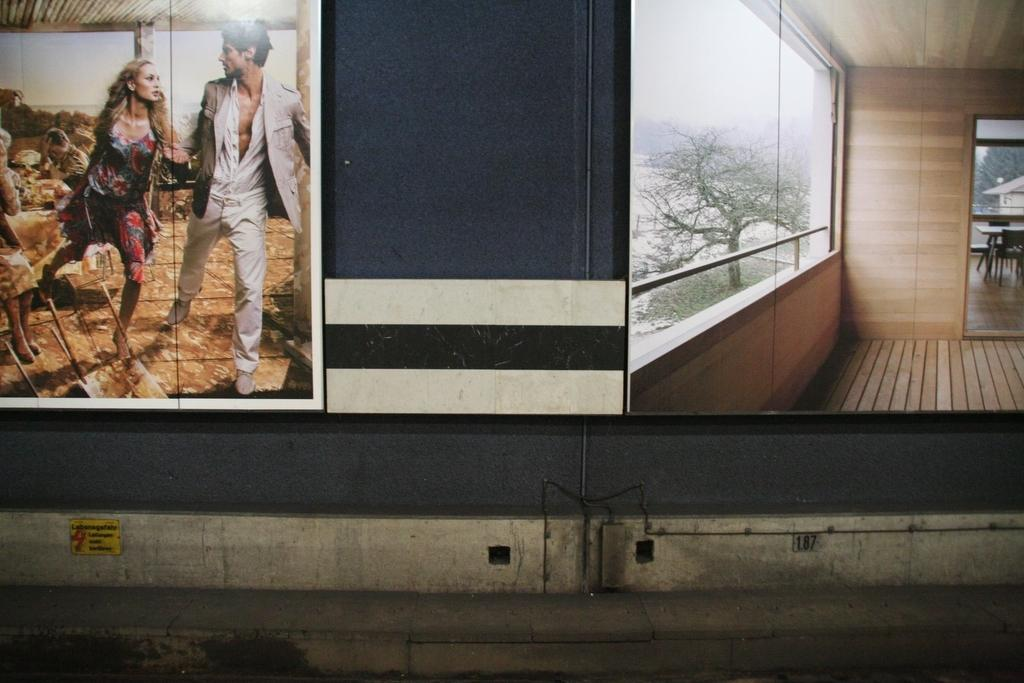What is attached to the wall in the image? There is a wall hanging attached to the wall in the image. What type of furniture can be seen in the image? There is a dining table in the image. What type of vegetation is present in the image? Trees are present in the image. What is visible in the background of the image? The sky is visible in the image. Can you tell me how many farmers are present in the image? There are no farmers present in the image. What type of growth can be seen on the trees in the image? There is no specific growth mentioned on the trees in the image, only that trees are present. 